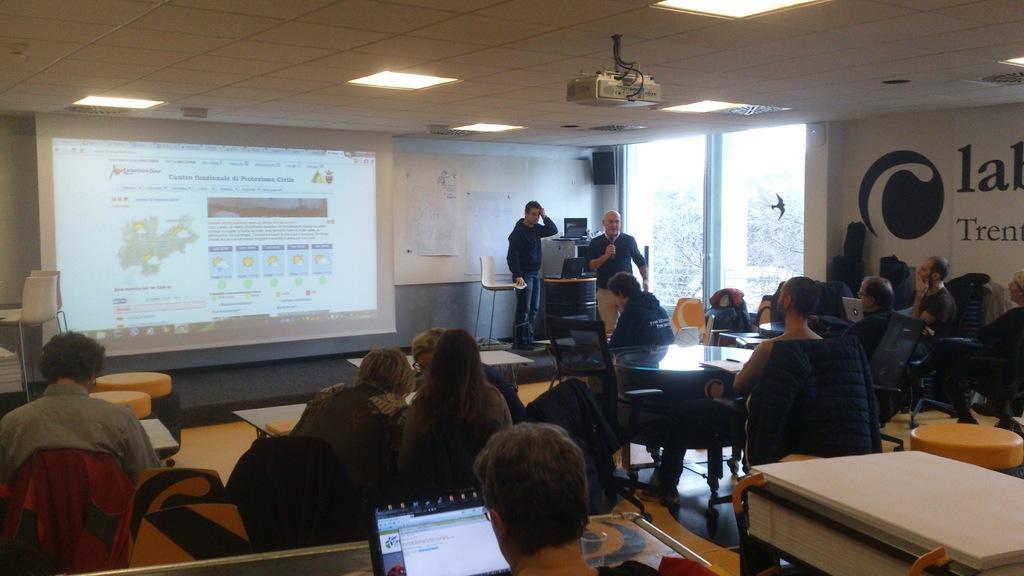How would you summarize this image in a sentence or two? This image is taken inside a room. There are many people in this room. In the left side of the image few people are sitting on the chairs. In the right side of the image there is an empty table and few of them are sitting on the chairs. In the background there is a wall with charts, projector screen and windows. At the top of the image there is a ceiling with lights, two men are standing on the dais. 